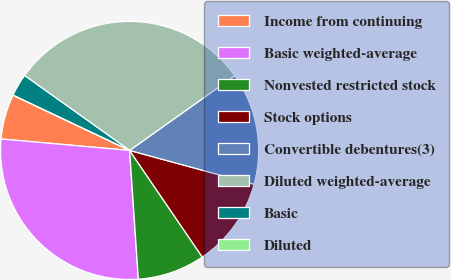Convert chart. <chart><loc_0><loc_0><loc_500><loc_500><pie_chart><fcel>Income from continuing<fcel>Basic weighted-average<fcel>Nonvested restricted stock<fcel>Stock options<fcel>Convertible debentures(3)<fcel>Diluted weighted-average<fcel>Basic<fcel>Diluted<nl><fcel>5.63%<fcel>27.5%<fcel>8.44%<fcel>11.25%<fcel>14.06%<fcel>30.31%<fcel>2.81%<fcel>0.0%<nl></chart> 